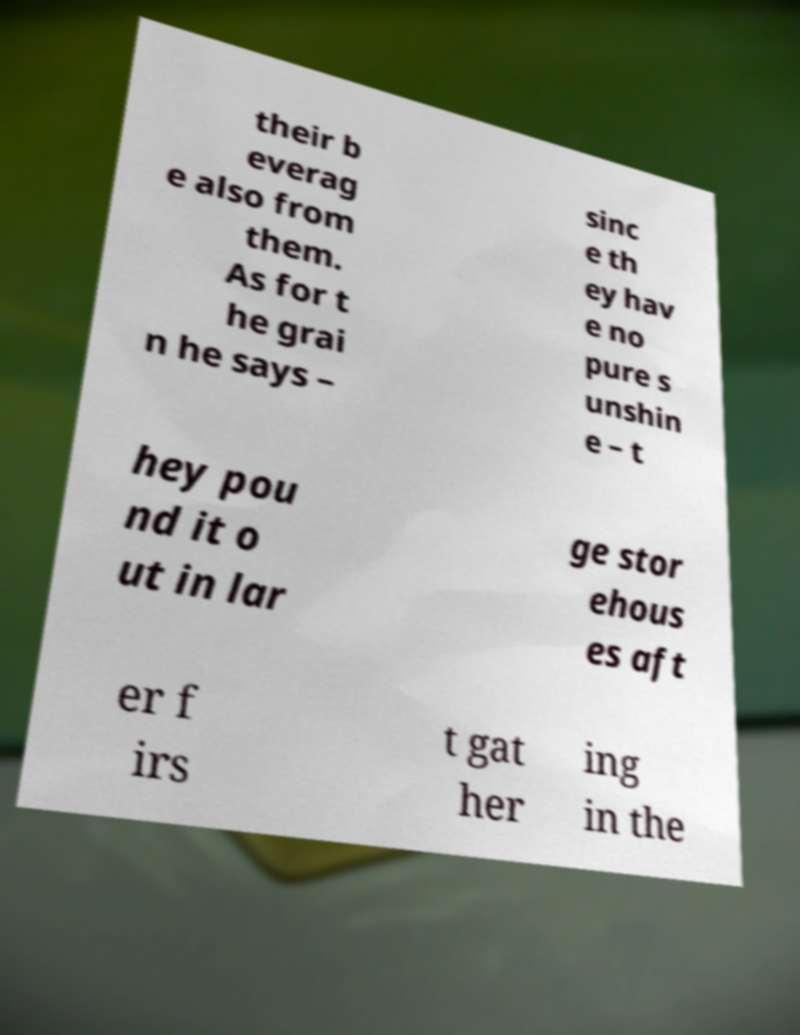Please identify and transcribe the text found in this image. their b everag e also from them. As for t he grai n he says – sinc e th ey hav e no pure s unshin e – t hey pou nd it o ut in lar ge stor ehous es aft er f irs t gat her ing in the 